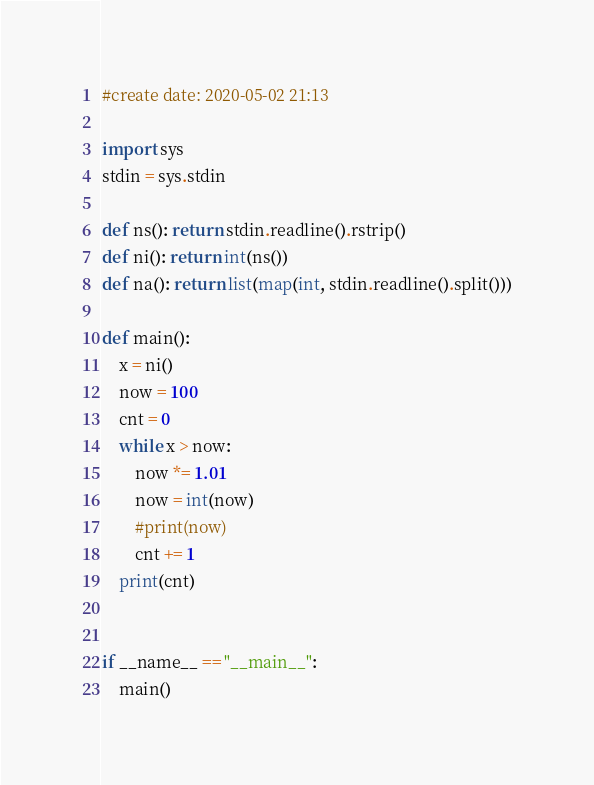<code> <loc_0><loc_0><loc_500><loc_500><_Python_>#create date: 2020-05-02 21:13

import sys
stdin = sys.stdin

def ns(): return stdin.readline().rstrip()
def ni(): return int(ns())
def na(): return list(map(int, stdin.readline().split()))

def main():
    x = ni()
    now = 100
    cnt = 0
    while x > now:
        now *= 1.01
        now = int(now)
        #print(now)
        cnt += 1
    print(cnt)


if __name__ == "__main__":
    main()</code> 